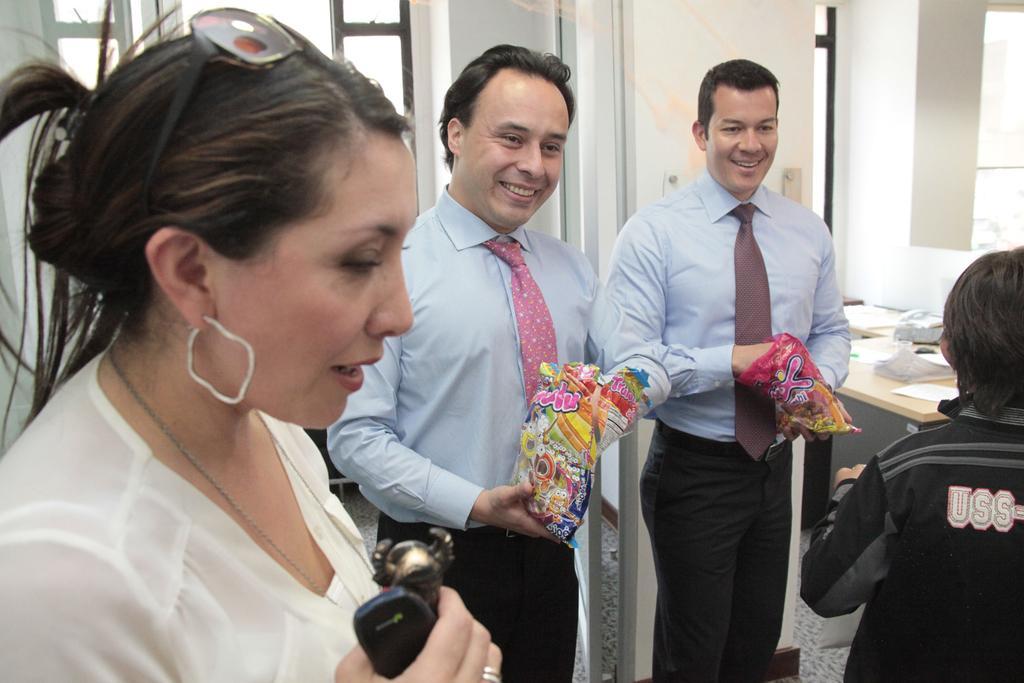In one or two sentences, can you explain what this image depicts? In this picture there are two persons wearing blue shirts are standing and holding a cover in their hands which has few objects in it and there is a woman standing beside them and holding two objects in her hand and there is a kid standing in the right corner and there is a table which has few objects placed on it in the background. 